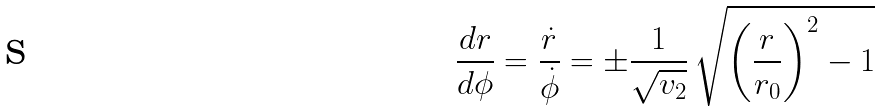Convert formula to latex. <formula><loc_0><loc_0><loc_500><loc_500>\frac { d r } { d \phi } = \frac { \dot { r } } { \dot { \phi } } = \pm \frac { 1 } { \sqrt { v _ { 2 } } } \, \sqrt { \left ( \frac { r } { r _ { 0 } } \right ) ^ { 2 } - 1 }</formula> 